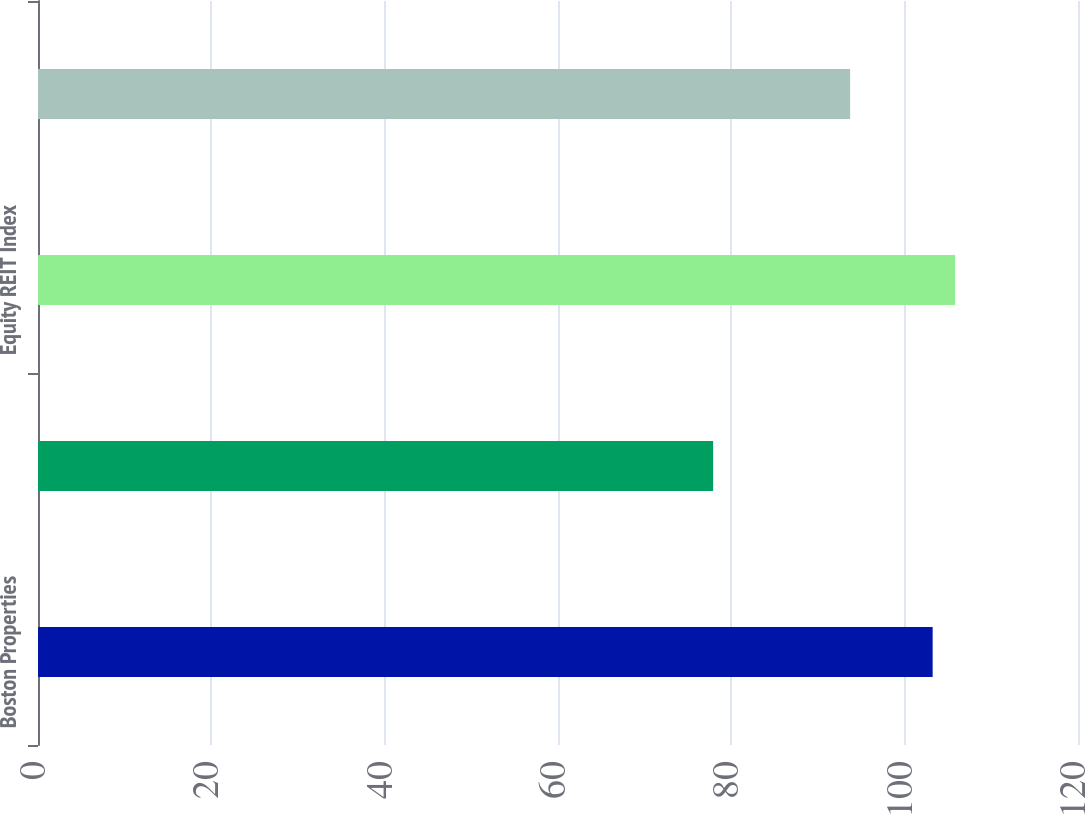Convert chart. <chart><loc_0><loc_0><loc_500><loc_500><bar_chart><fcel>Boston Properties<fcel>S&P500<fcel>Equity REIT Index<fcel>Office REIT Index<nl><fcel>103.23<fcel>77.9<fcel>105.82<fcel>93.71<nl></chart> 